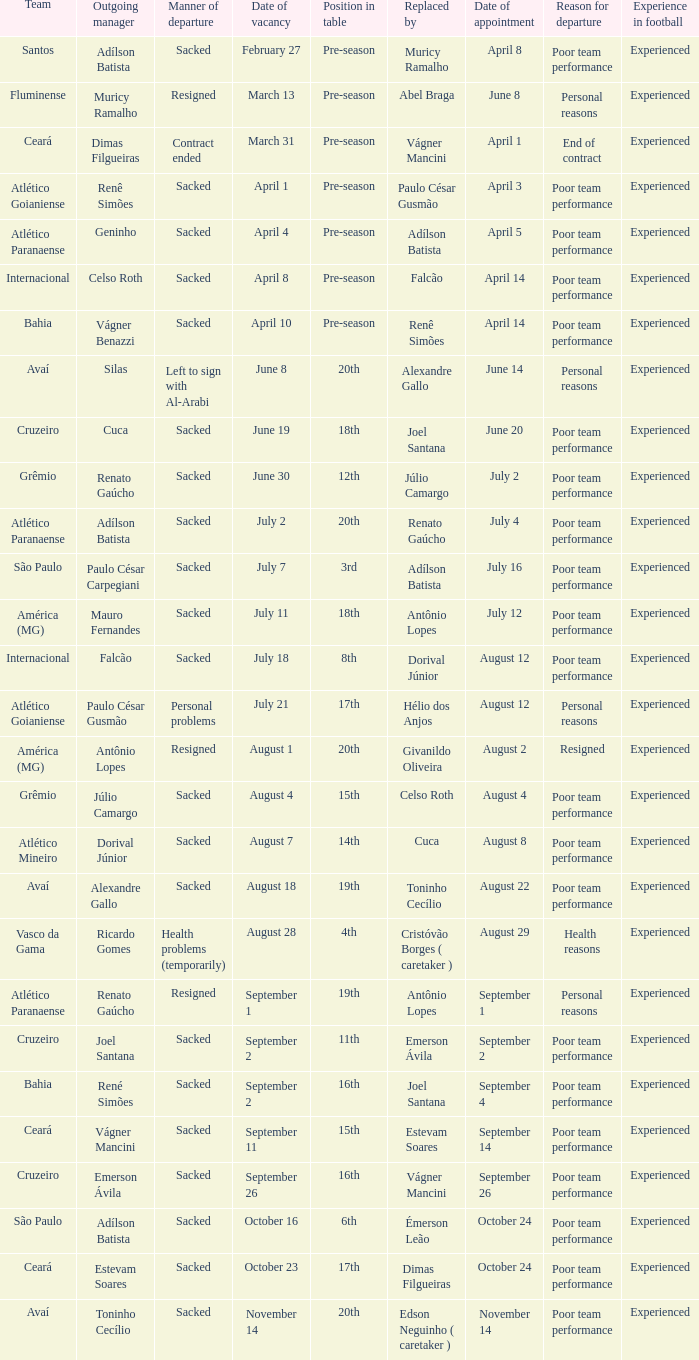Why did Geninho leave as manager? Sacked. 